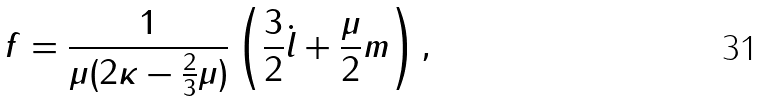<formula> <loc_0><loc_0><loc_500><loc_500>f = \frac { 1 } { \mu ( 2 \kappa - \frac { 2 } { 3 } \mu ) } \left ( \frac { 3 } { 2 } \dot { l } + \frac { \mu } { 2 } m \right ) ,</formula> 